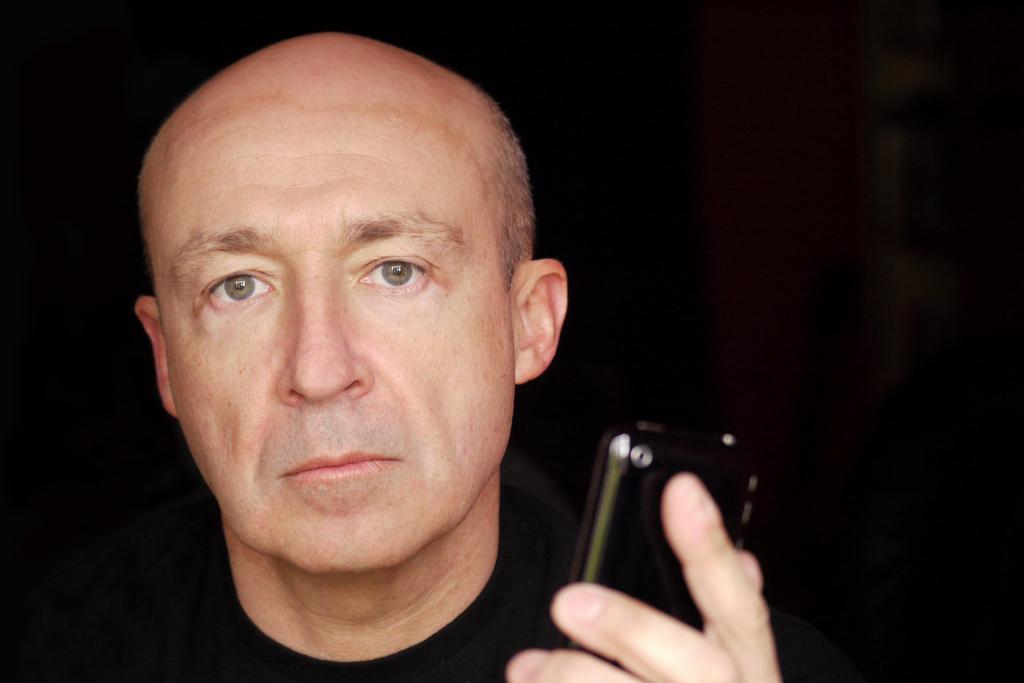What is the main subject of the image? There is a man in the image. What is the man holding in the image? The man is holding a mobile phone. What type of plants can be seen growing on the man's head in the image? There are no plants visible on the man's head in the image. 